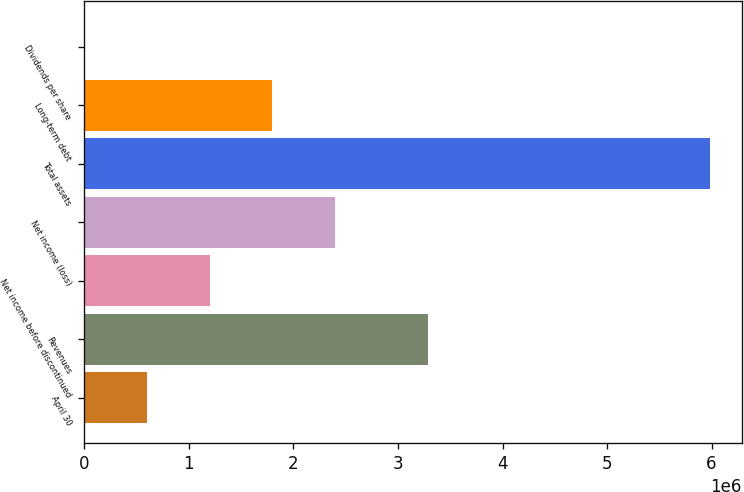Convert chart. <chart><loc_0><loc_0><loc_500><loc_500><bar_chart><fcel>April 30<fcel>Revenues<fcel>Net income before discontinued<fcel>Net income (loss)<fcel>Total assets<fcel>Long-term debt<fcel>Dividends per share<nl><fcel>598914<fcel>3.2868e+06<fcel>1.19783e+06<fcel>2.39565e+06<fcel>5.98914e+06<fcel>1.79674e+06<fcel>0.49<nl></chart> 